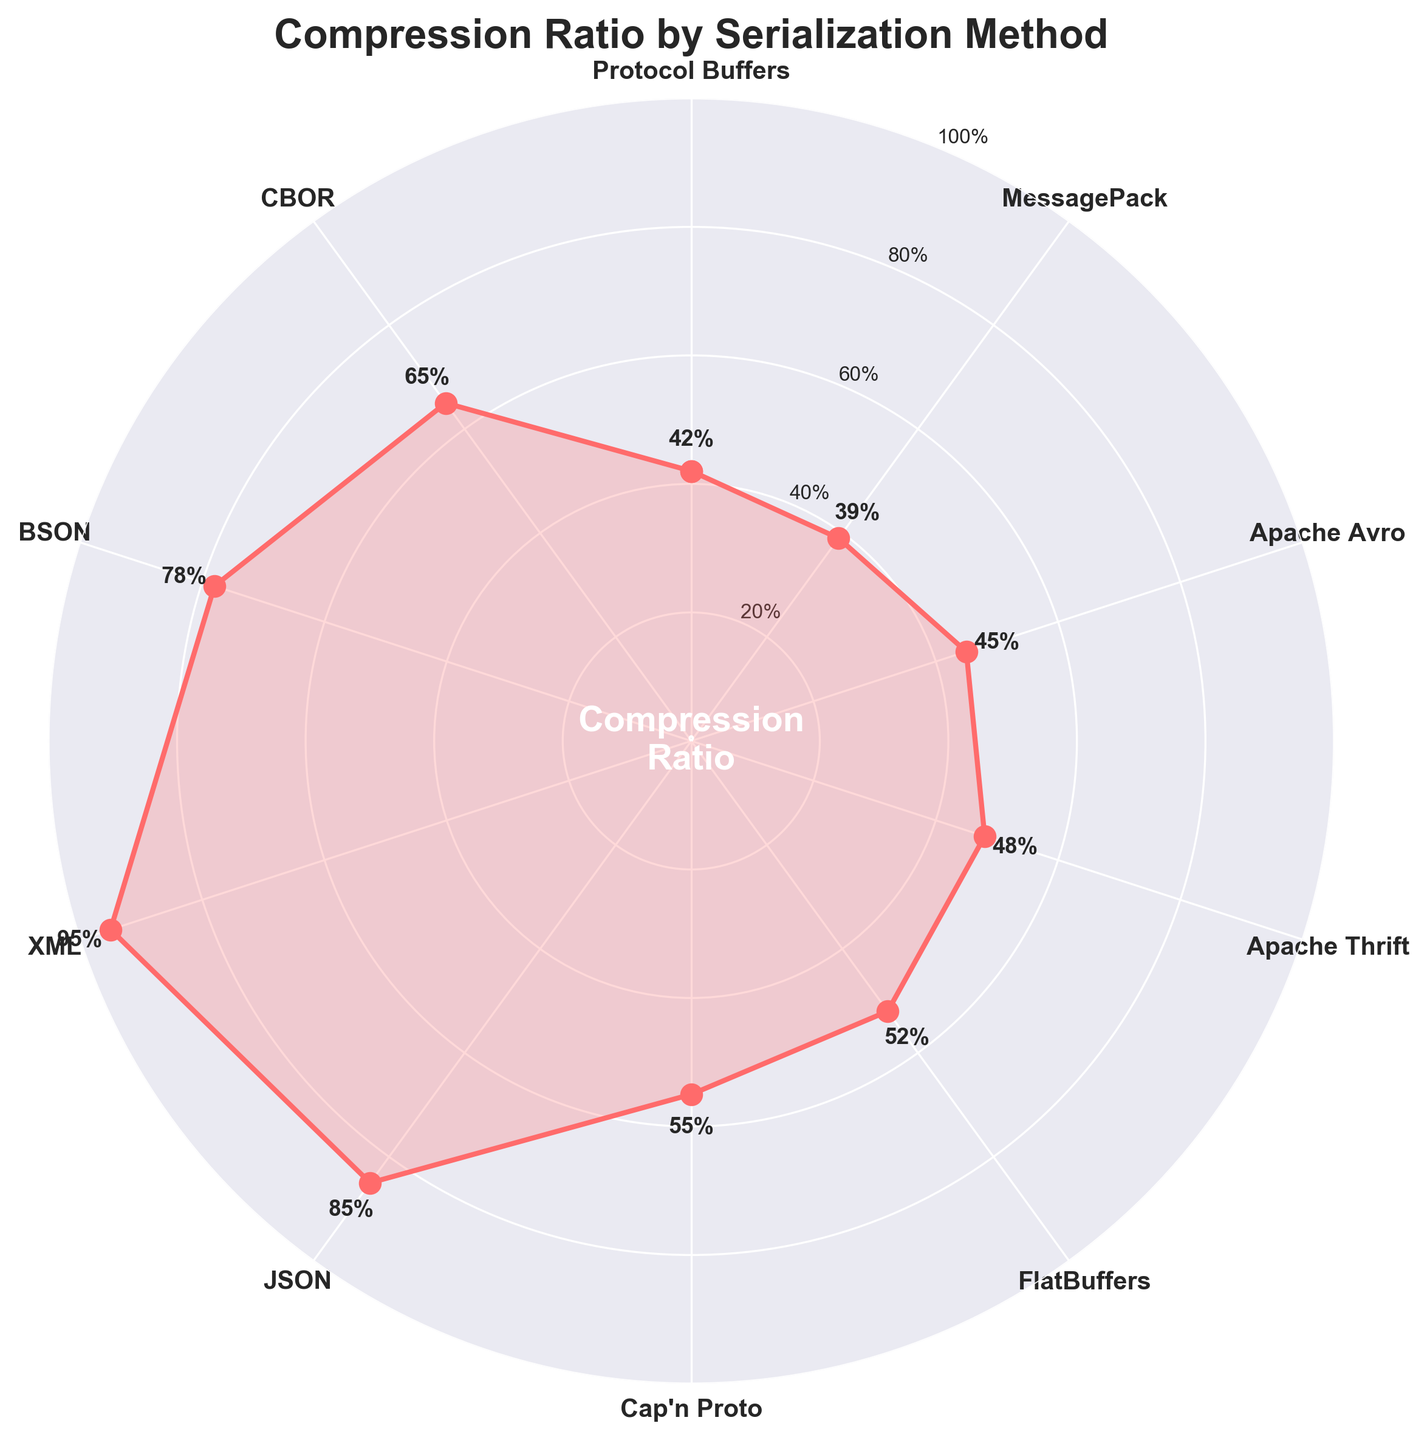What is the title of the plot? The title of the plot is found at the top center of the figure, which helps understand what the figure represents. The title is "Compression Ratio by Serialization Method."
Answer: Compression Ratio by Serialization Method How many serialization methods are displayed in the figure? To determine the number of methods, count the unique labels along the circumference of the plot. Each label represents a serialization method. There are 10 serialization methods displayed.
Answer: 10 Which serialization method achieved the highest compression ratio? Look for the method that corresponds to the highest percentage value along the plot's radial lines. The method with the highest compression ratio is XML at 95%.
Answer: XML What is the compression ratio for BSON? Find the label "BSON" along the circumference and check the corresponding percentage value. BSON's compression ratio is 78%.
Answer: 78% Which method achieved a lower compression ratio, MessagePack or CBOR? Compare the percentages for MessagePack and CBOR. MessagePack is at 39%, while CBOR is at 65%. Hence, MessagePack has a lower compression ratio.
Answer: MessagePack What is the average compression ratio of Protocol Buffers, Apache Thrift, and FlatBuffers? First, find the values for Protocol Buffers, Apache Thrift, and FlatBuffers, which are 42%, 48%, and 52%, respectively. Then, average these values: (42 + 48 + 52) / 3 = 47.33%.
Answer: 47.33% How much greater is the compression ratio of XML compared to JSON? Check the values for XML and JSON, which are 95% and 85%, respectively. Subtract the JSON value from the XML value: 95% - 85% = 10%.
Answer: 10% Which methods have a compression ratio higher than 50%? Identify the methods whose percentages along the plot are greater than 50%. The methods are FlatBuffers (52%), Cap'n Proto (55%), JSON (85%), XML (95%), BSON (78%), and CBOR (65%).
Answer: FlatBuffers, Cap'n Proto, JSON, XML, BSON, CBOR Between Protocol Buffers and Apache Avro, which method has a lower compression ratio? Compare the percentages for Protocol Buffers and Apache Avro, which are 42% and 45% respectively. Protocol Buffers has a lower compression ratio.
Answer: Protocol Buffers What is the difference in compression ratio between Cap'n Proto and Apache Thrift? Subtract the value for Apache Thrift from the value for Cap'n Proto. Cap'n Proto is at 55% and Apache Thrift is at 48%. So, the difference is 55% - 48% = 7%.
Answer: 7% 